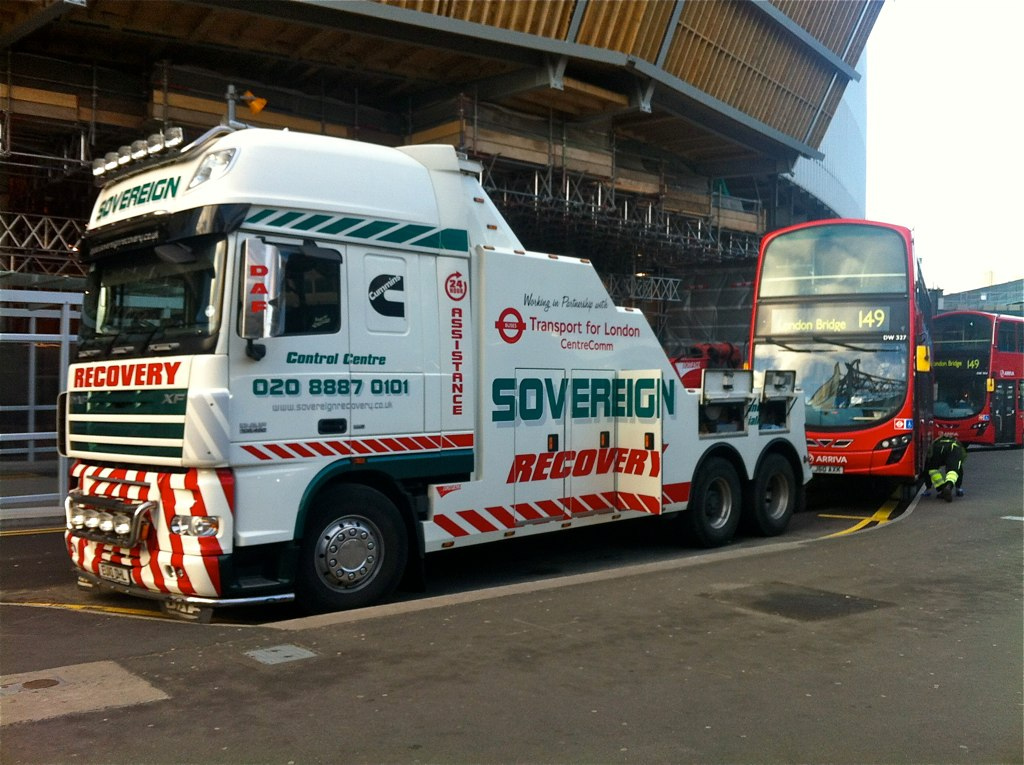Is there anything unique about this truck's design? The truck features highly reflective safety stripes and bright lighting to increase its visibility, especially during road recovery operations at night or in poor visibility conditions. The design emphasizes safety for both the operator and surrounding traffic. 